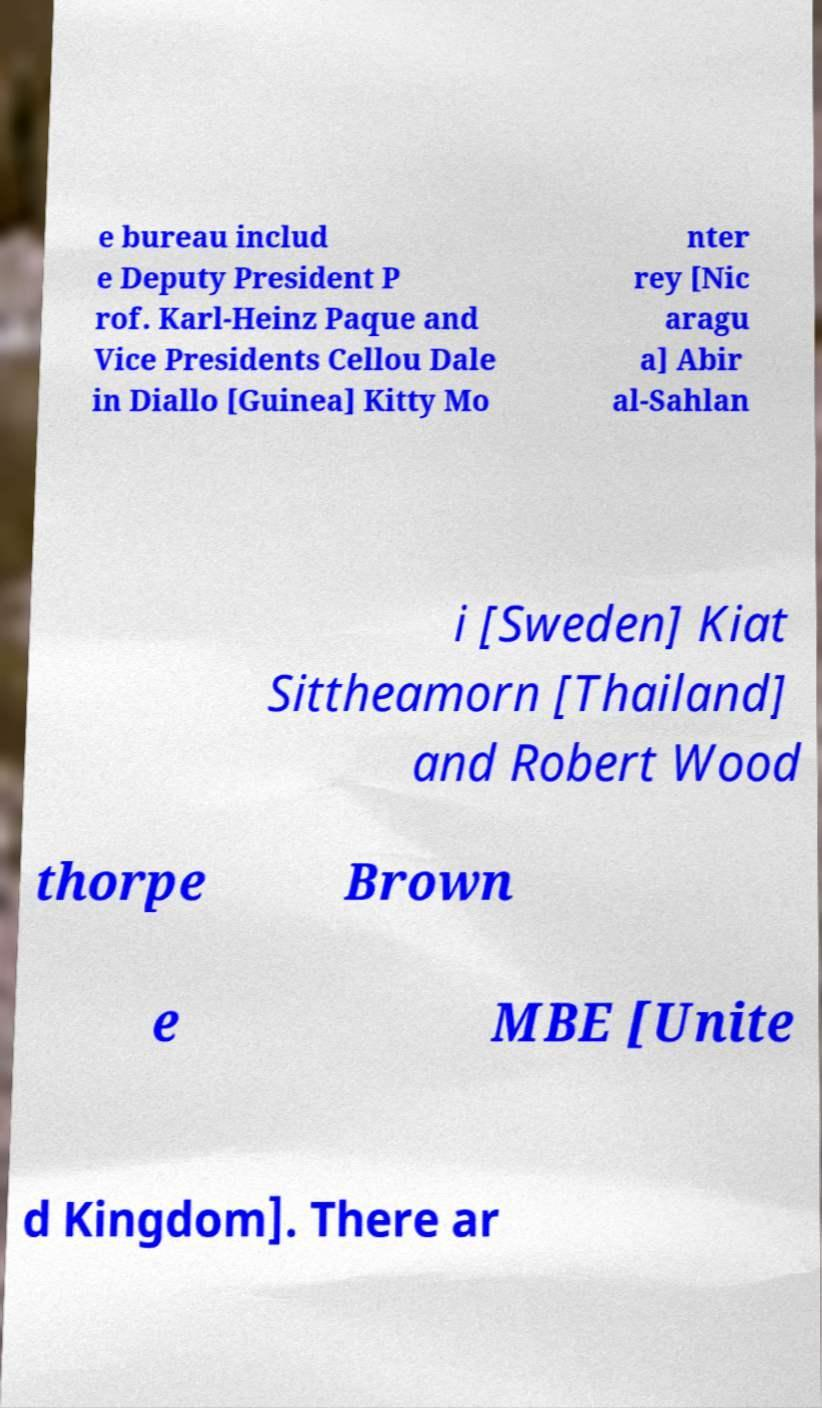Please read and relay the text visible in this image. What does it say? e bureau includ e Deputy President P rof. Karl-Heinz Paque and Vice Presidents Cellou Dale in Diallo [Guinea] Kitty Mo nter rey [Nic aragu a] Abir al-Sahlan i [Sweden] Kiat Sittheamorn [Thailand] and Robert Wood thorpe Brown e MBE [Unite d Kingdom]. There ar 